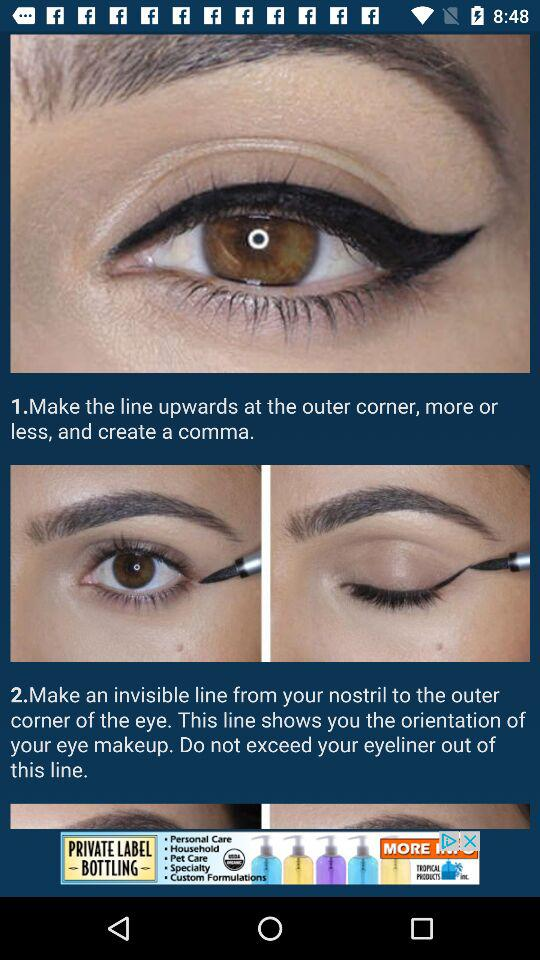How many steps are there in the tutorial?
Answer the question using a single word or phrase. 2 